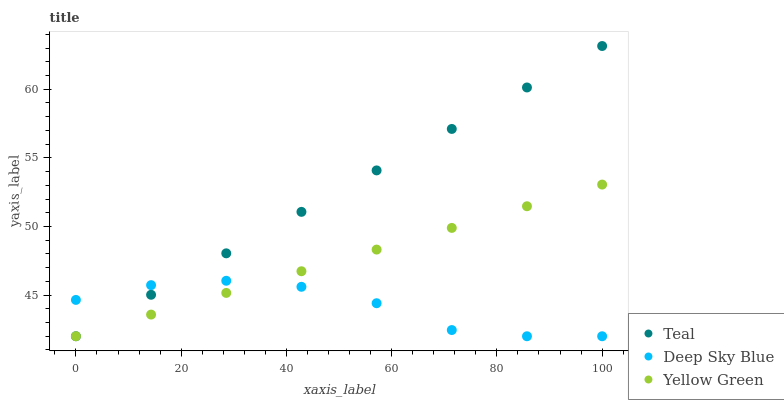Does Deep Sky Blue have the minimum area under the curve?
Answer yes or no. Yes. Does Teal have the maximum area under the curve?
Answer yes or no. Yes. Does Yellow Green have the minimum area under the curve?
Answer yes or no. No. Does Yellow Green have the maximum area under the curve?
Answer yes or no. No. Is Yellow Green the smoothest?
Answer yes or no. Yes. Is Deep Sky Blue the roughest?
Answer yes or no. Yes. Is Teal the smoothest?
Answer yes or no. No. Is Teal the roughest?
Answer yes or no. No. Does Deep Sky Blue have the lowest value?
Answer yes or no. Yes. Does Teal have the highest value?
Answer yes or no. Yes. Does Yellow Green have the highest value?
Answer yes or no. No. Does Teal intersect Yellow Green?
Answer yes or no. Yes. Is Teal less than Yellow Green?
Answer yes or no. No. Is Teal greater than Yellow Green?
Answer yes or no. No. 